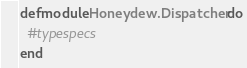<code> <loc_0><loc_0><loc_500><loc_500><_Elixir_>defmodule Honeydew.Dispatcher do
  #typespecs
end
</code> 